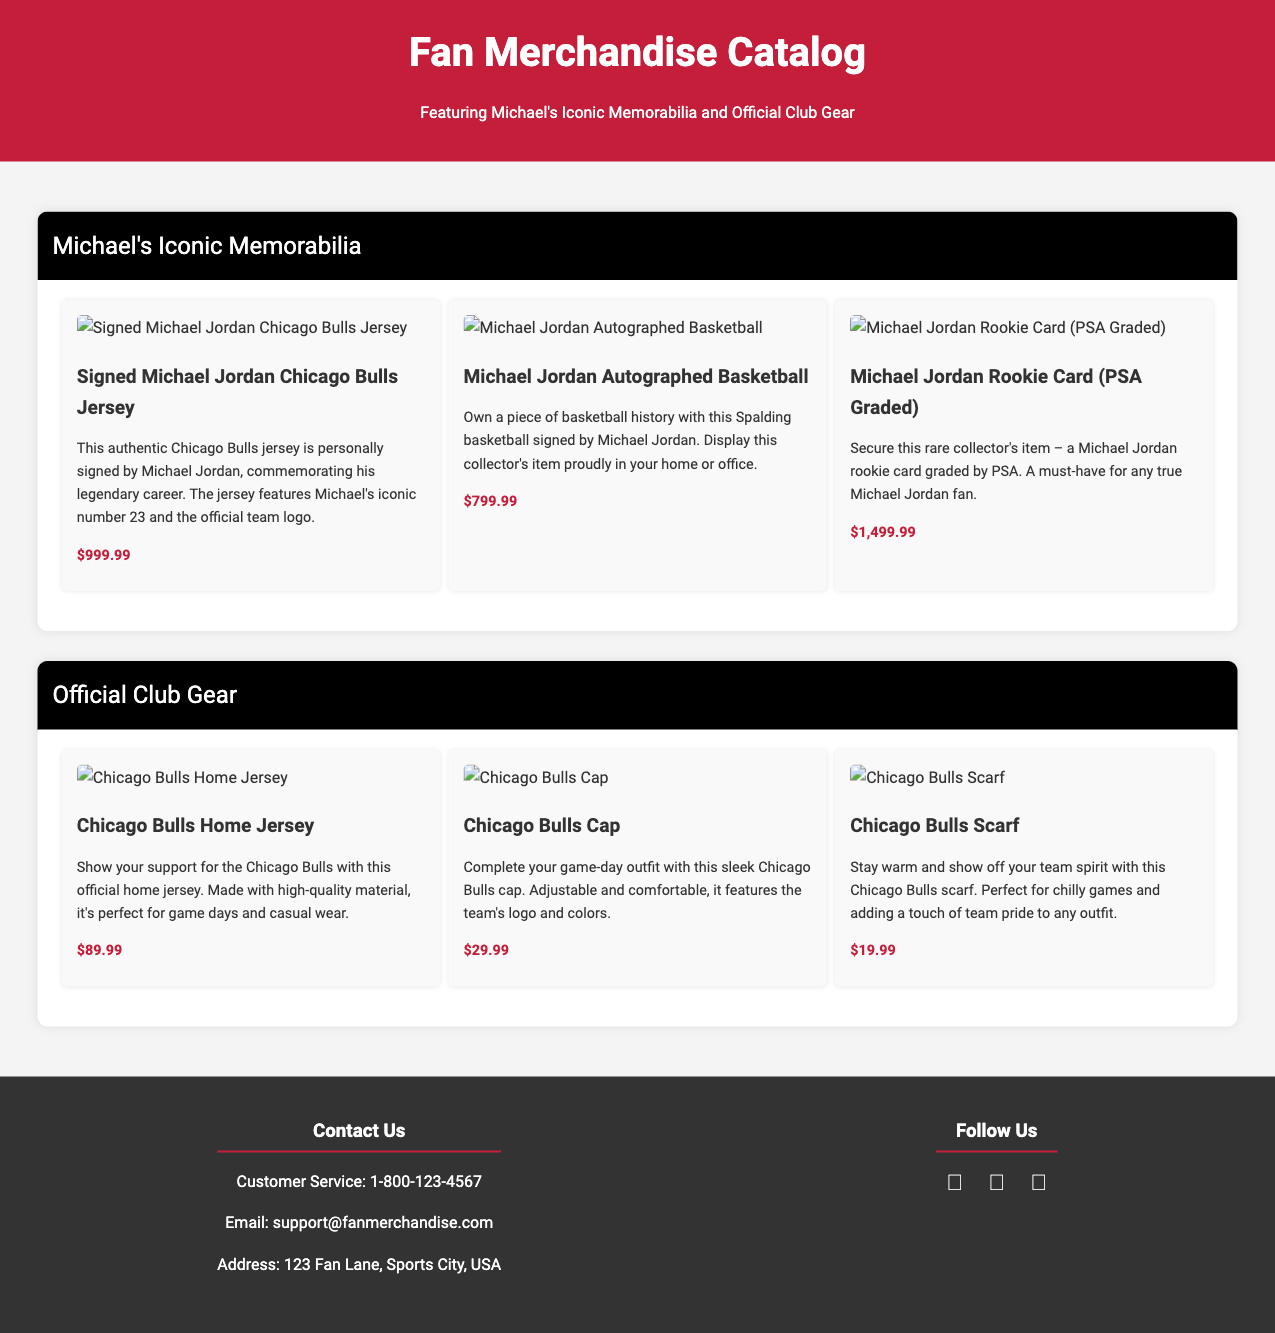what is the price of the Signed Michael Jordan Chicago Bulls Jersey? The price for the Signed Michael Jordan Chicago Bulls Jersey is listed in the document under its description, which is $999.99.
Answer: $999.99 how many items are featured under Michael's Iconic Memorabilia? The section for Michael's Iconic Memorabilia lists three different items available for purchase.
Answer: 3 what is the official team logo featured on the Signed Michael Jordan Chicago Bulls Jersey? The document mentions that the jersey features Michael's iconic number 23 and the official team logo, which is the Chicago Bulls logo.
Answer: Chicago Bulls what is the price of the Chicago Bulls Scarf? The price of the Chicago Bulls Scarf is specified in the document, which is $19.99.
Answer: $19.99 which iconic memorabilia has the highest price? By reviewing the prices listed for each iconic memorabilia, the Michael Jordan Rookie Card is the item with the highest price.
Answer: Michael Jordan Rookie Card what type of item is the Michael Jordan Autographed Basketball? The document describes this item as a basketball that has been autographed, indicating it is a collectible sports equipment piece.
Answer: basketball how many sections are included in the Fan Merchandise Catalog? The document contains two distinct sections, one for Michael's Iconic Memorabilia and another for Official Club Gear.
Answer: 2 what is the email address provided for customer service? The document includes an email for customer service inquiries, which is support@fanmerchandise.com.
Answer: support@fanmerchandise.com 